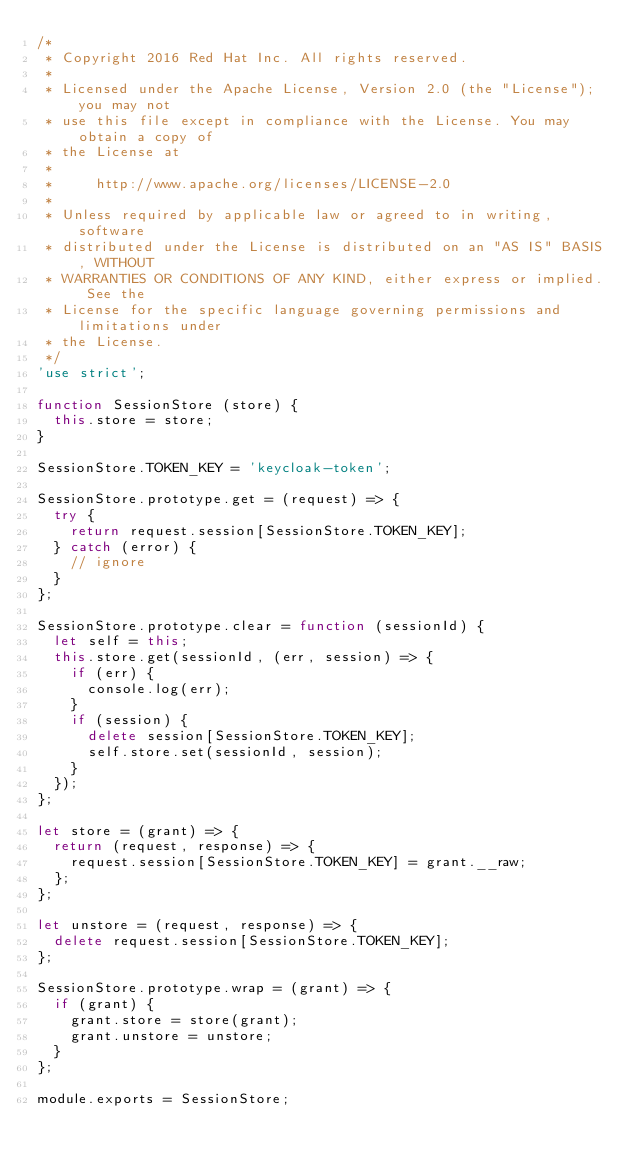<code> <loc_0><loc_0><loc_500><loc_500><_JavaScript_>/*
 * Copyright 2016 Red Hat Inc. All rights reserved.
 *
 * Licensed under the Apache License, Version 2.0 (the "License"); you may not
 * use this file except in compliance with the License. You may obtain a copy of
 * the License at
 *
 *     http://www.apache.org/licenses/LICENSE-2.0
 *
 * Unless required by applicable law or agreed to in writing, software
 * distributed under the License is distributed on an "AS IS" BASIS, WITHOUT
 * WARRANTIES OR CONDITIONS OF ANY KIND, either express or implied. See the
 * License for the specific language governing permissions and limitations under
 * the License.
 */
'use strict';

function SessionStore (store) {
  this.store = store;
}

SessionStore.TOKEN_KEY = 'keycloak-token';

SessionStore.prototype.get = (request) => {
  try {
    return request.session[SessionStore.TOKEN_KEY];
  } catch (error) {
    // ignore
  }
};

SessionStore.prototype.clear = function (sessionId) {
  let self = this;
  this.store.get(sessionId, (err, session) => {
    if (err) {
      console.log(err);
    }
    if (session) {
      delete session[SessionStore.TOKEN_KEY];
      self.store.set(sessionId, session);
    }
  });
};

let store = (grant) => {
  return (request, response) => {
    request.session[SessionStore.TOKEN_KEY] = grant.__raw;
  };
};

let unstore = (request, response) => {
  delete request.session[SessionStore.TOKEN_KEY];
};

SessionStore.prototype.wrap = (grant) => {
  if (grant) {
    grant.store = store(grant);
    grant.unstore = unstore;
  }
};

module.exports = SessionStore;
</code> 